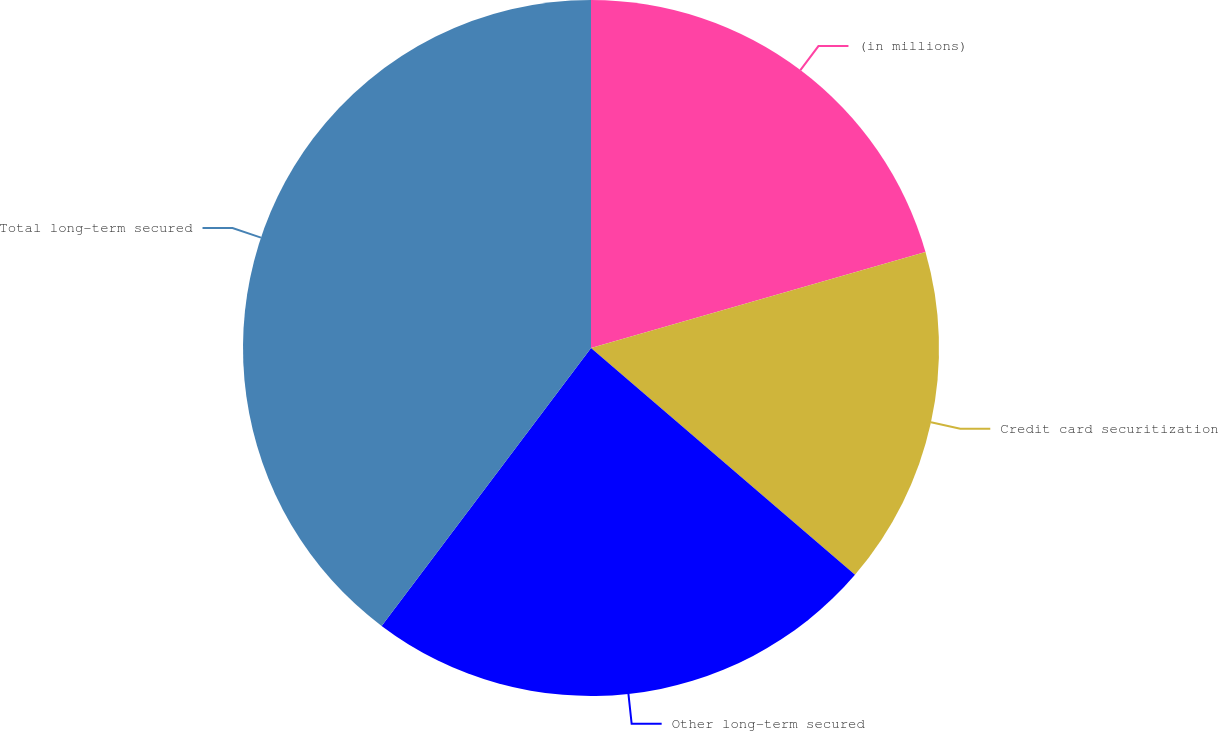<chart> <loc_0><loc_0><loc_500><loc_500><pie_chart><fcel>(in millions)<fcel>Credit card securitization<fcel>Other long-term secured<fcel>Total long-term secured<nl><fcel>20.55%<fcel>15.74%<fcel>23.98%<fcel>39.72%<nl></chart> 